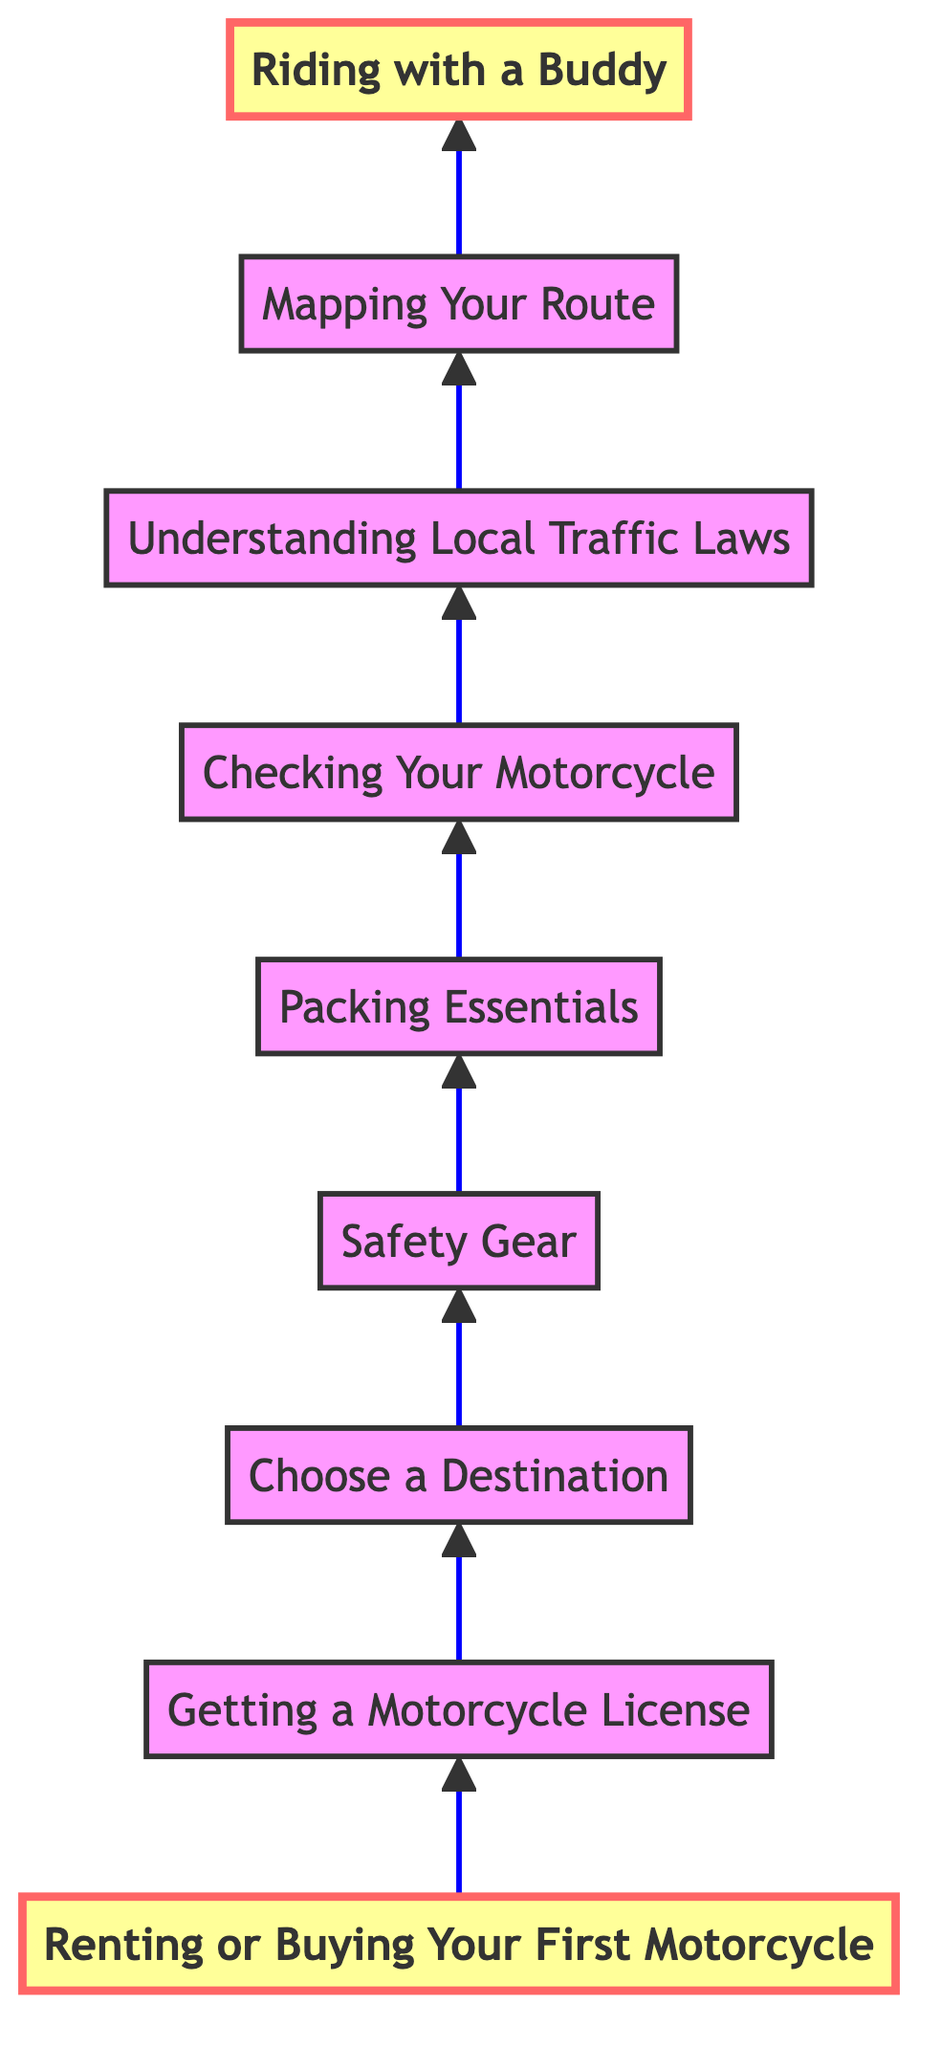What is the first step in planning your motorcycle trip? The first step in the diagram is "Renting or Buying Your First Motorcycle," which indicates that this decision should be made before proceeding further with any trip planning.
Answer: Renting or Buying Your First Motorcycle How many nodes are in the diagram? The diagram includes a total of 9 nodes, each representing a step in the motorcycle trip planning process, starting from renting or buying a motorcycle to riding with a buddy.
Answer: 9 What comes after "Understanding Local Traffic Laws"? The diagram indicates that "Mapping Your Route" comes directly after "Understanding Local Traffic Laws," showing a clear progression in the planning steps.
Answer: Mapping Your Route Which step is the last in the planning process? According to the flow chart, the last step in the planning process is "Riding with a Buddy," as it is positioned at the top of the flow chart.
Answer: Riding with a Buddy Why is "Safety Gear" important in the trip planning flow? "Safety Gear" is crucial as it highlights the importance of protective equipment for rider safety. It's a key step between destination choice and packing essentials, indicating its necessity in the sequence of preparation.
Answer: Protective equipment How many steps are there between "Choose a Destination" and "Packing Essentials"? There are two steps between "Choose a Destination" and "Packing Essentials": "Safety Gear" and "Checking Your Motorcycle," which are sequentially essential for trip preparation.
Answer: 2 Which node is highlighted in the diagram? The nodes highlighted in the diagram are "Renting or Buying Your First Motorcycle" and "Riding with a Buddy," indicating their significance in the overall planning process.
Answer: Renting or Buying Your First Motorcycle, Riding with a Buddy What is the relationship between "Getting a Motorcycle License" and "Choose a Destination"? The relationship is sequential; "Getting a Motorcycle License" is the step that must be completed before one can "Choose a Destination," indicating a necessary prerequisite.
Answer: Prerequisite What does the upward arrow in the diagram signify? The upward arrow in the flow chart signifies the flow of steps in the planning process, indicating that each step must be completed in order as one moves toward the final goal of the trip.
Answer: Flow of steps 